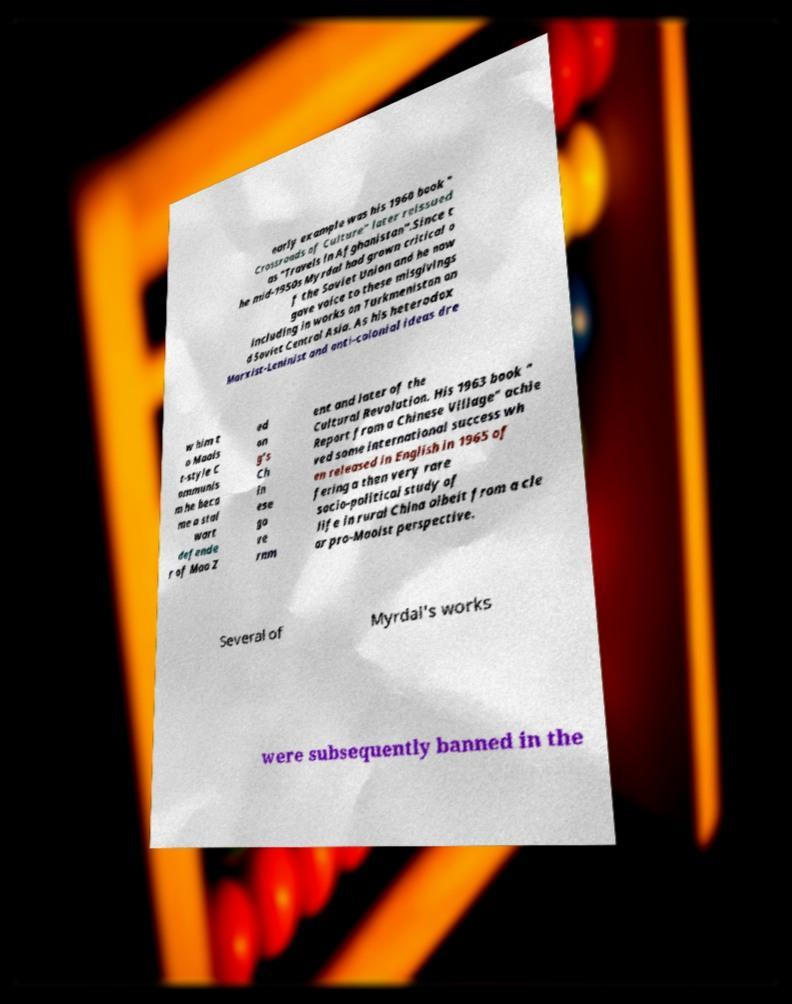I need the written content from this picture converted into text. Can you do that? early example was his 1960 book " Crossroads of Culture" later reissued as "Travels in Afghanistan".Since t he mid-1950s Myrdal had grown critical o f the Soviet Union and he now gave voice to these misgivings including in works on Turkmenistan an d Soviet Central Asia. As his heterodox Marxist-Leninist and anti-colonial ideas dre w him t o Maois t-style C ommunis m he beca me a stal wart defende r of Mao Z ed on g's Ch in ese go ve rnm ent and later of the Cultural Revolution. His 1963 book " Report from a Chinese Village" achie ved some international success wh en released in English in 1965 of fering a then very rare socio-political study of life in rural China albeit from a cle ar pro-Maoist perspective. Several of Myrdal's works were subsequently banned in the 